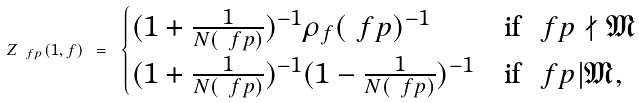<formula> <loc_0><loc_0><loc_500><loc_500>Z _ { \ f p } ( 1 , f ) \ = \ \begin{cases} ( 1 + \frac { 1 } { N ( \ f p ) } ) ^ { - 1 } \rho _ { f } ( \ f p ) ^ { - 1 } & \text {if} \ \ f p \nmid \mathfrak { M } \\ ( 1 + \frac { 1 } { N ( \ f p ) } ) ^ { - 1 } ( 1 - \frac { 1 } { N ( \ f p ) } ) ^ { - 1 } & \text {if} \ \ f p | \mathfrak { M } , \end{cases}</formula> 